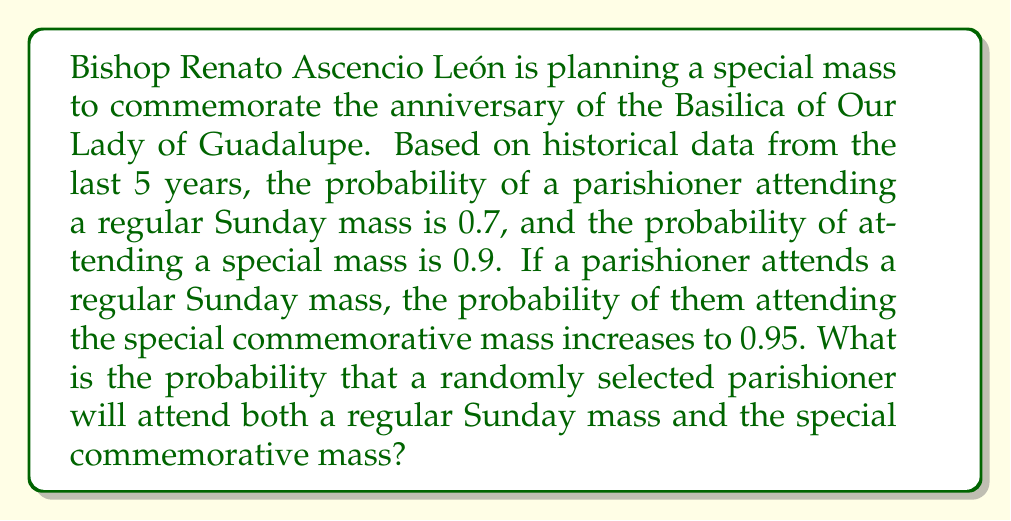Solve this math problem. To solve this problem, we'll use the concept of conditional probability and the multiplication rule of probability.

Let's define our events:
A: Attending a regular Sunday mass
B: Attending the special commemorative mass

We're given the following probabilities:
P(A) = 0.7 (probability of attending a regular Sunday mass)
P(B) = 0.9 (probability of attending the special mass)
P(B|A) = 0.95 (probability of attending the special mass given that they attend a regular Sunday mass)

We want to find P(A and B), which is the probability of attending both masses.

Using the multiplication rule of probability:

$$ P(A \text{ and } B) = P(A) \cdot P(B|A) $$

Substituting the given values:

$$ P(A \text{ and } B) = 0.7 \cdot 0.95 $$

$$ P(A \text{ and } B) = 0.665 $$

Therefore, the probability that a randomly selected parishioner will attend both a regular Sunday mass and the special commemorative mass is 0.665 or 66.5%.
Answer: 0.665 or 66.5% 